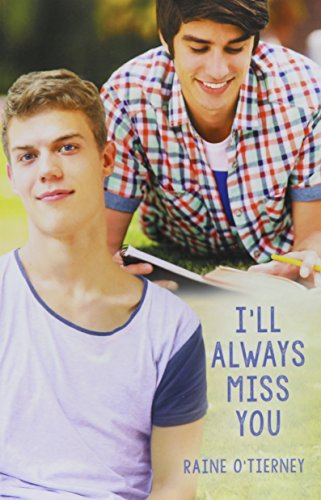How does the visual design of this cover relate to the story in the book? The cover design features two young individuals in a serene outdoor setting, suggesting themes of close relationships and poignant moments which mirror the emotional and interpersonal explorations within the story. 